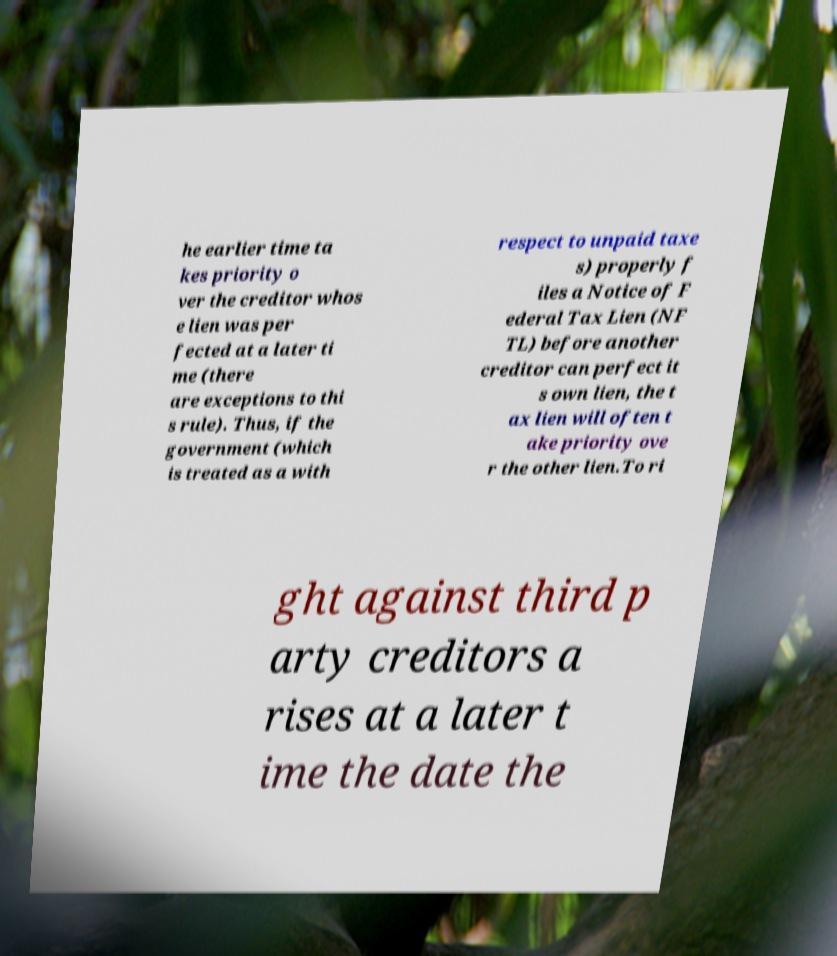Can you read and provide the text displayed in the image?This photo seems to have some interesting text. Can you extract and type it out for me? he earlier time ta kes priority o ver the creditor whos e lien was per fected at a later ti me (there are exceptions to thi s rule). Thus, if the government (which is treated as a with respect to unpaid taxe s) properly f iles a Notice of F ederal Tax Lien (NF TL) before another creditor can perfect it s own lien, the t ax lien will often t ake priority ove r the other lien.To ri ght against third p arty creditors a rises at a later t ime the date the 